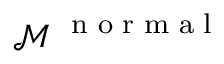<formula> <loc_0><loc_0><loc_500><loc_500>\mathcal { M } ^ { n o r m a l }</formula> 